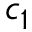Convert formula to latex. <formula><loc_0><loc_0><loc_500><loc_500>c _ { 1 }</formula> 